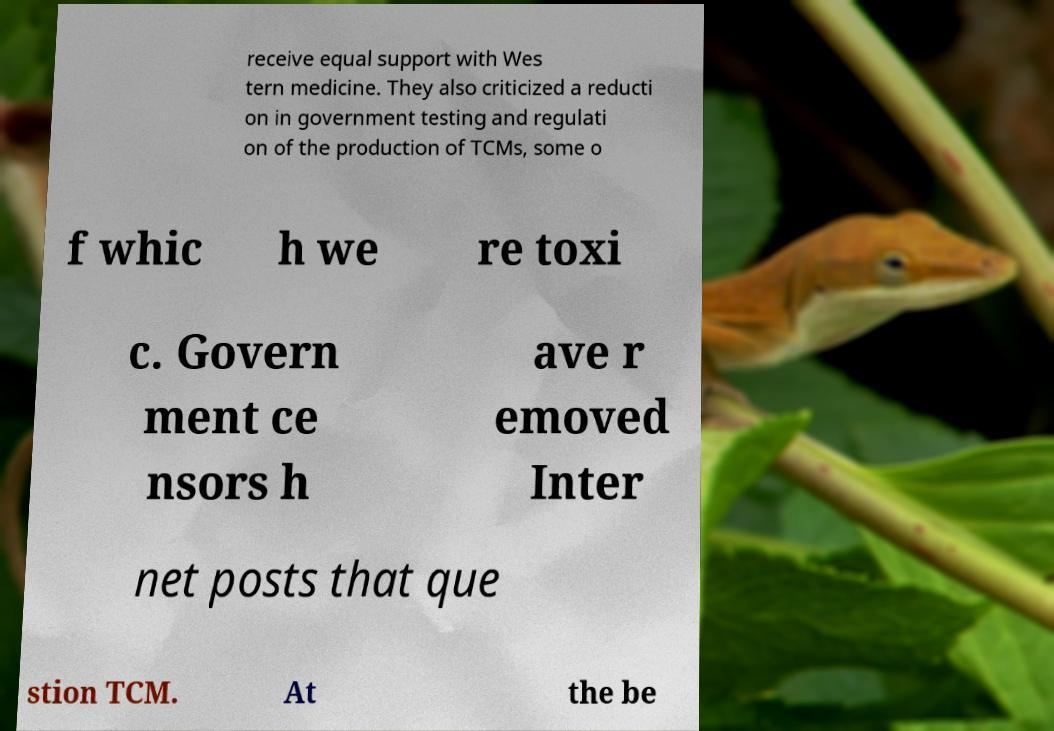Please read and relay the text visible in this image. What does it say? receive equal support with Wes tern medicine. They also criticized a reducti on in government testing and regulati on of the production of TCMs, some o f whic h we re toxi c. Govern ment ce nsors h ave r emoved Inter net posts that que stion TCM. At the be 